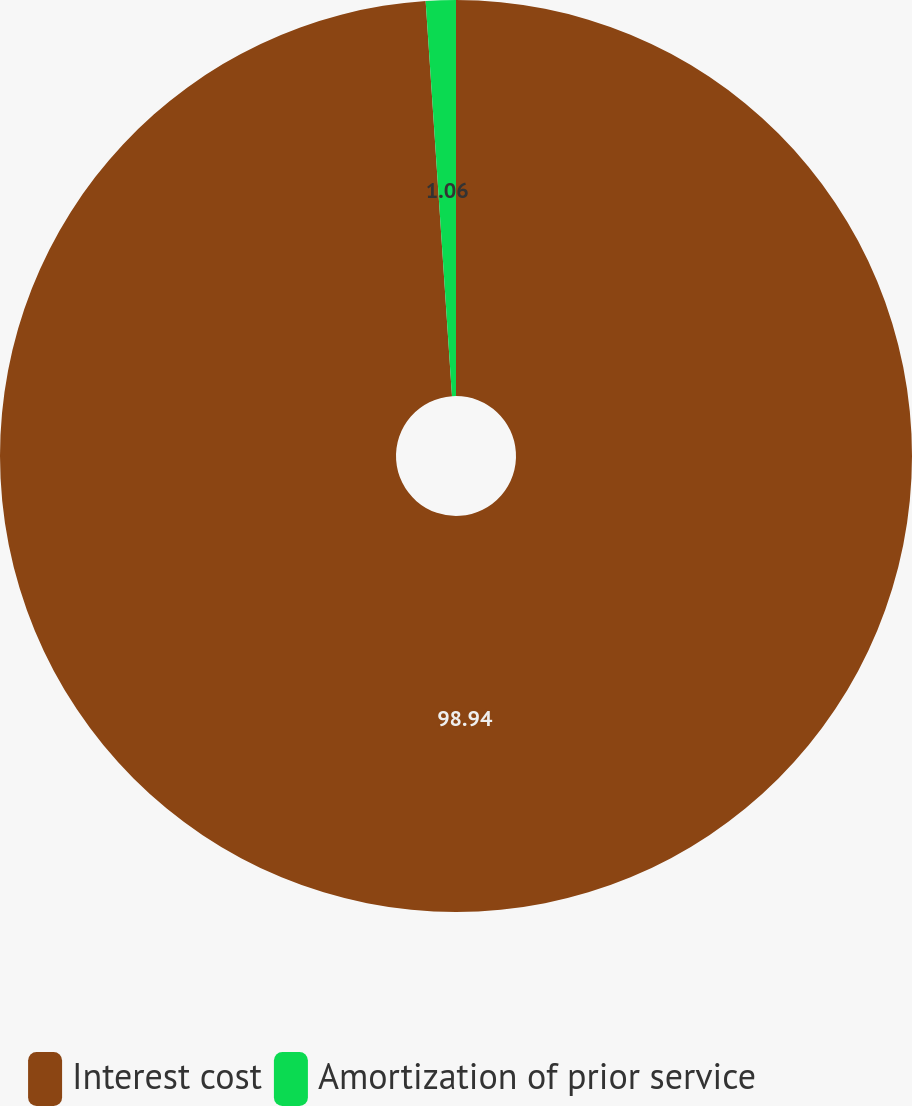Convert chart. <chart><loc_0><loc_0><loc_500><loc_500><pie_chart><fcel>Interest cost<fcel>Amortization of prior service<nl><fcel>98.94%<fcel>1.06%<nl></chart> 